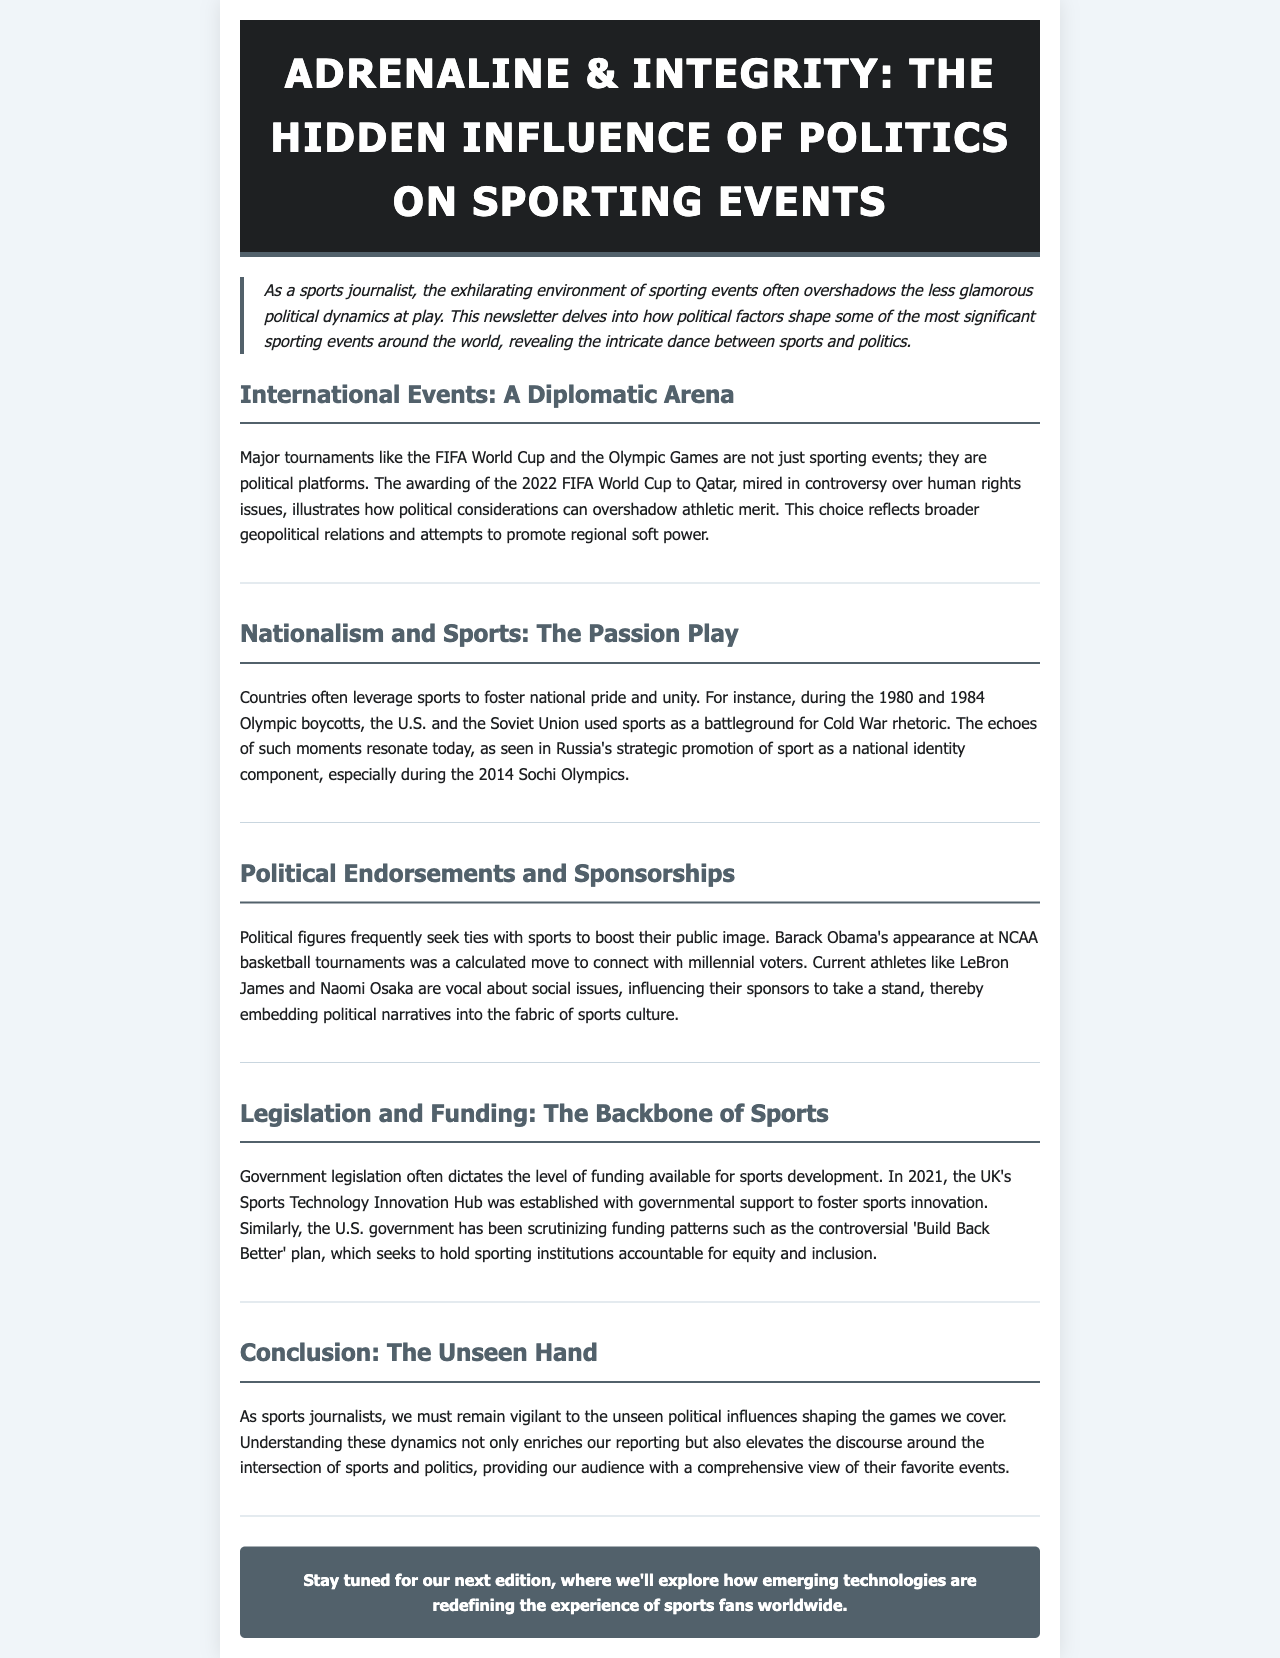What major tournaments are mentioned as political platforms? The document specifically mentions the FIFA World Cup and the Olympic Games as major tournaments that serve as political platforms.
Answer: FIFA World Cup and Olympic Games In what year were the Olympic boycotts that reflected Cold War tensions? The document refers to the Olympic boycotts of 1980 and 1984 during the Cold War as significant events reflecting national tensions.
Answer: 1980 and 1984 What initiative was established in the UK in 2021 to foster sports innovation? The document states that the Sports Technology Innovation Hub was established in the UK in 2021 to support sports innovation through government funding.
Answer: Sports Technology Innovation Hub Who made a calculated move to connect with millennial voters at NCAA tournaments? Barack Obama is mentioned in the document as having appeared at NCAA basketball tournaments to connect with millennial voters.
Answer: Barack Obama What is the main conclusion regarding political influences in sports reporting? The conclusion emphasizes the need for sports journalists to be aware of the unseen political influences that shape the sports they cover, enhancing their reporting.
Answer: The unseen political influences Why are sports significant for national pride and unity? The document discusses how countries use sports to foster national pride and unity, especially highlighted during the Olympic boycotts.
Answer: National pride and unity What term describes Russia's promotion of sports during the Sochi Olympics? The document indicates that Russia strategically promoted sport as a component of national identity during the 2014 Sochi Olympics.
Answer: National identity What does the newsletter suggest will be explored in the next edition? The document concludes with a teaser for the next edition, mentioning an exploration of how emerging technologies are redefining the fan experience in sports.
Answer: Emerging technologies 